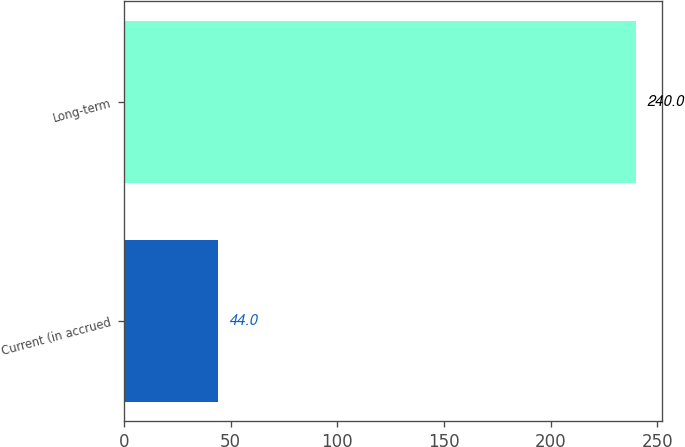Convert chart. <chart><loc_0><loc_0><loc_500><loc_500><bar_chart><fcel>Current (in accrued<fcel>Long-term<nl><fcel>44<fcel>240<nl></chart> 